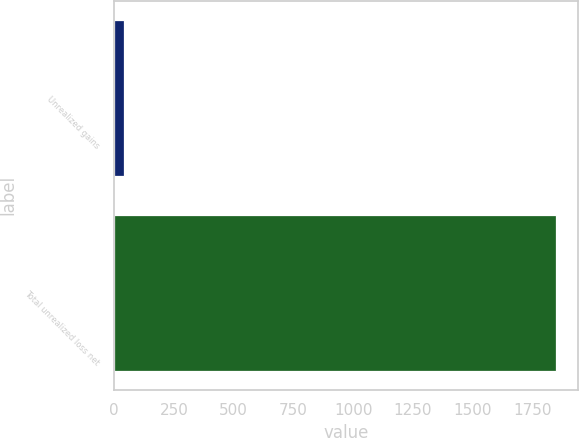Convert chart to OTSL. <chart><loc_0><loc_0><loc_500><loc_500><bar_chart><fcel>Unrealized gains<fcel>Total unrealized loss net<nl><fcel>41<fcel>1849<nl></chart> 